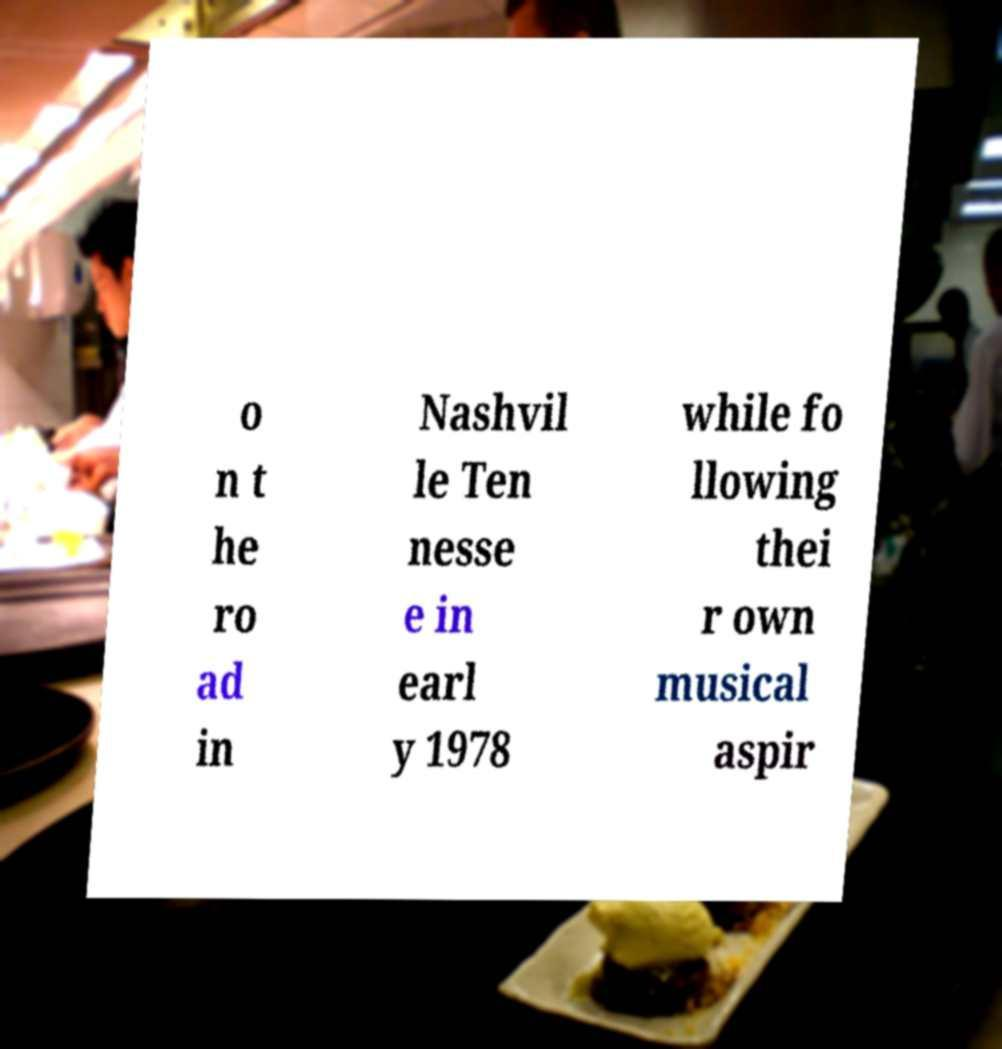Please identify and transcribe the text found in this image. o n t he ro ad in Nashvil le Ten nesse e in earl y 1978 while fo llowing thei r own musical aspir 